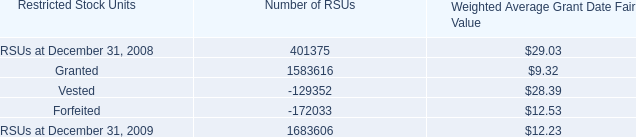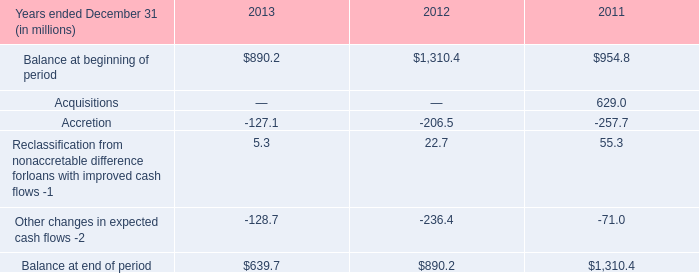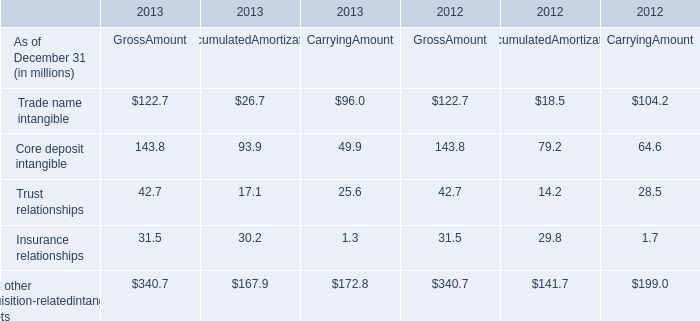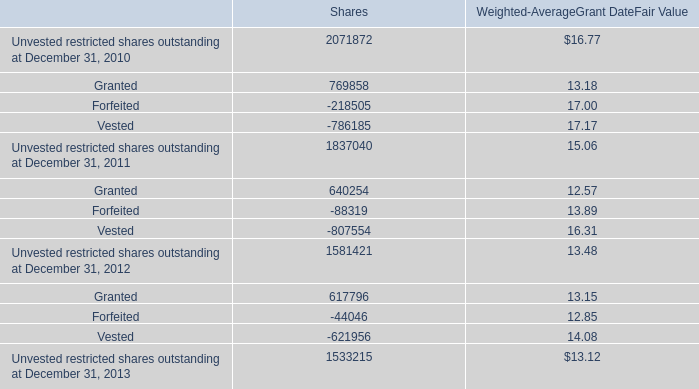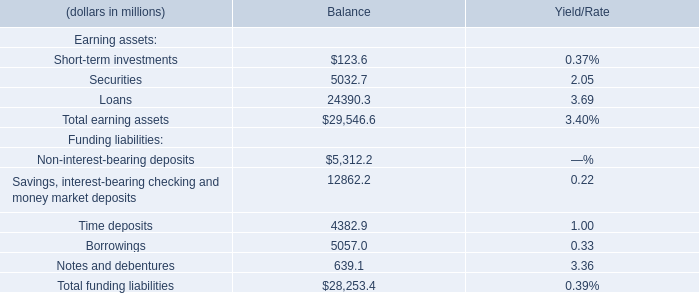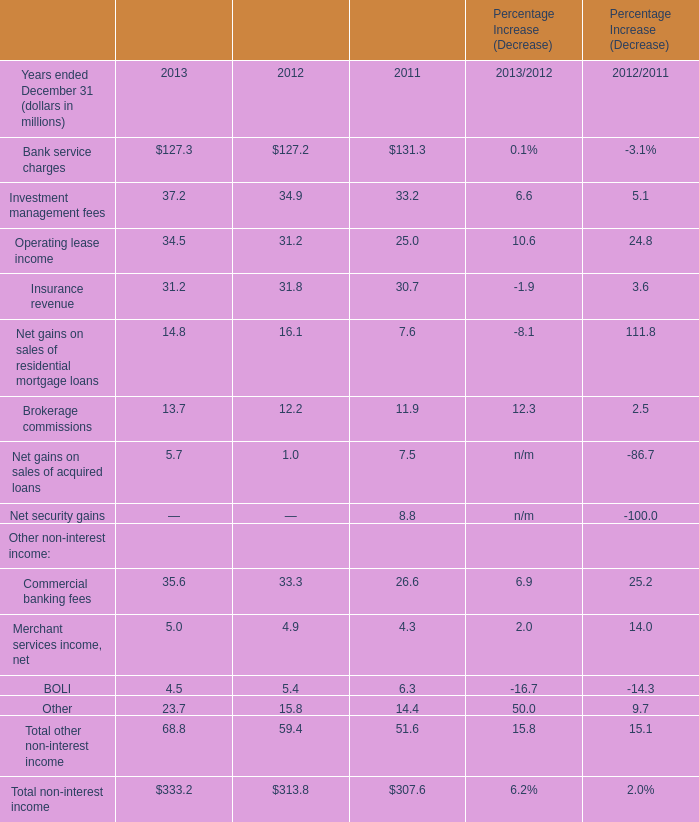What was the average value of Time deposits, Borrowings, Loans for Balance? (in million) 
Computations: (((4382.9 + 5057) + 24390.3) / 3)
Answer: 11276.73333. 